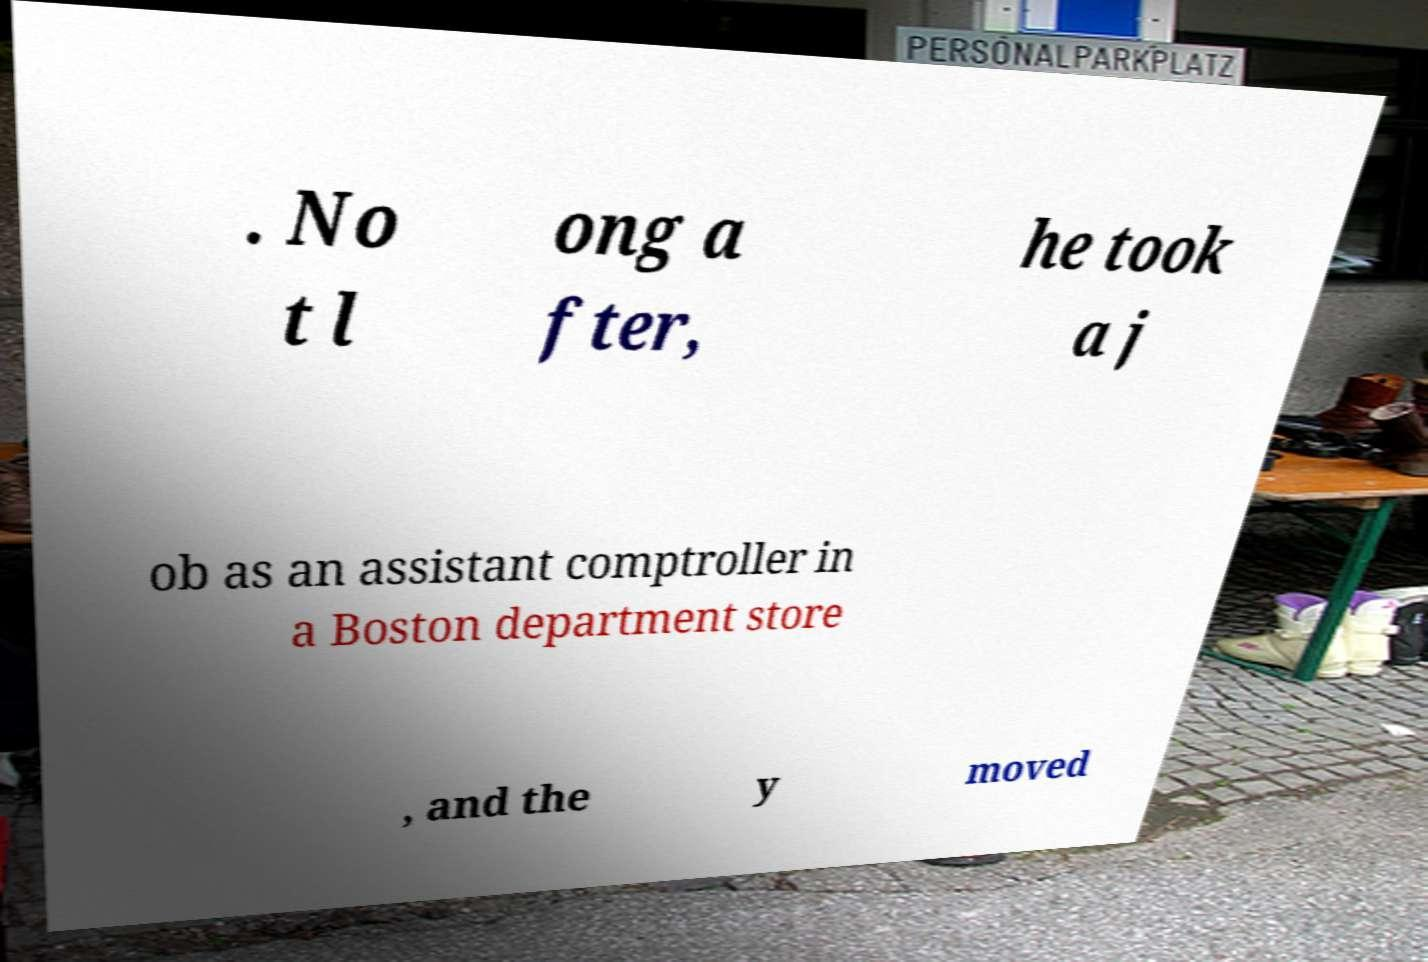Can you accurately transcribe the text from the provided image for me? . No t l ong a fter, he took a j ob as an assistant comptroller in a Boston department store , and the y moved 